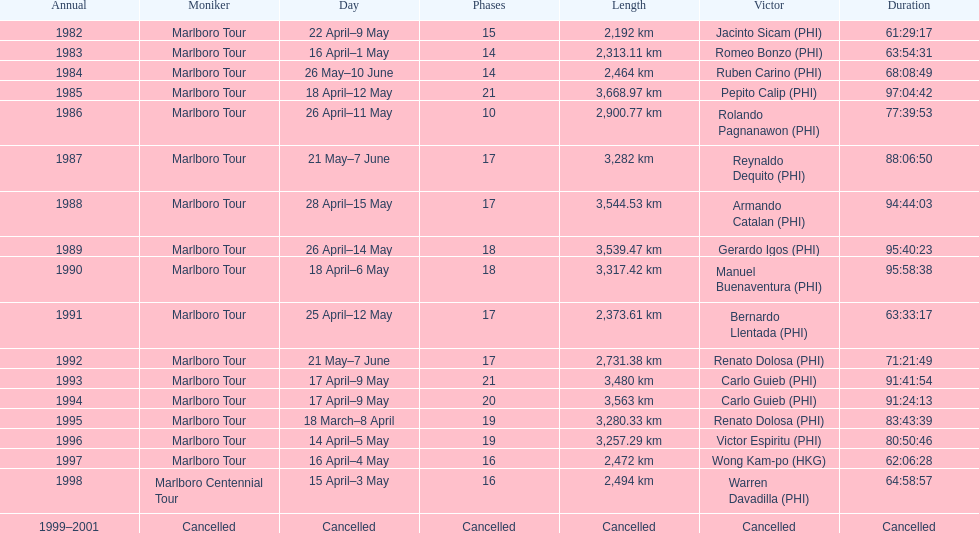Who is listed before wong kam-po? Victor Espiritu (PHI). 